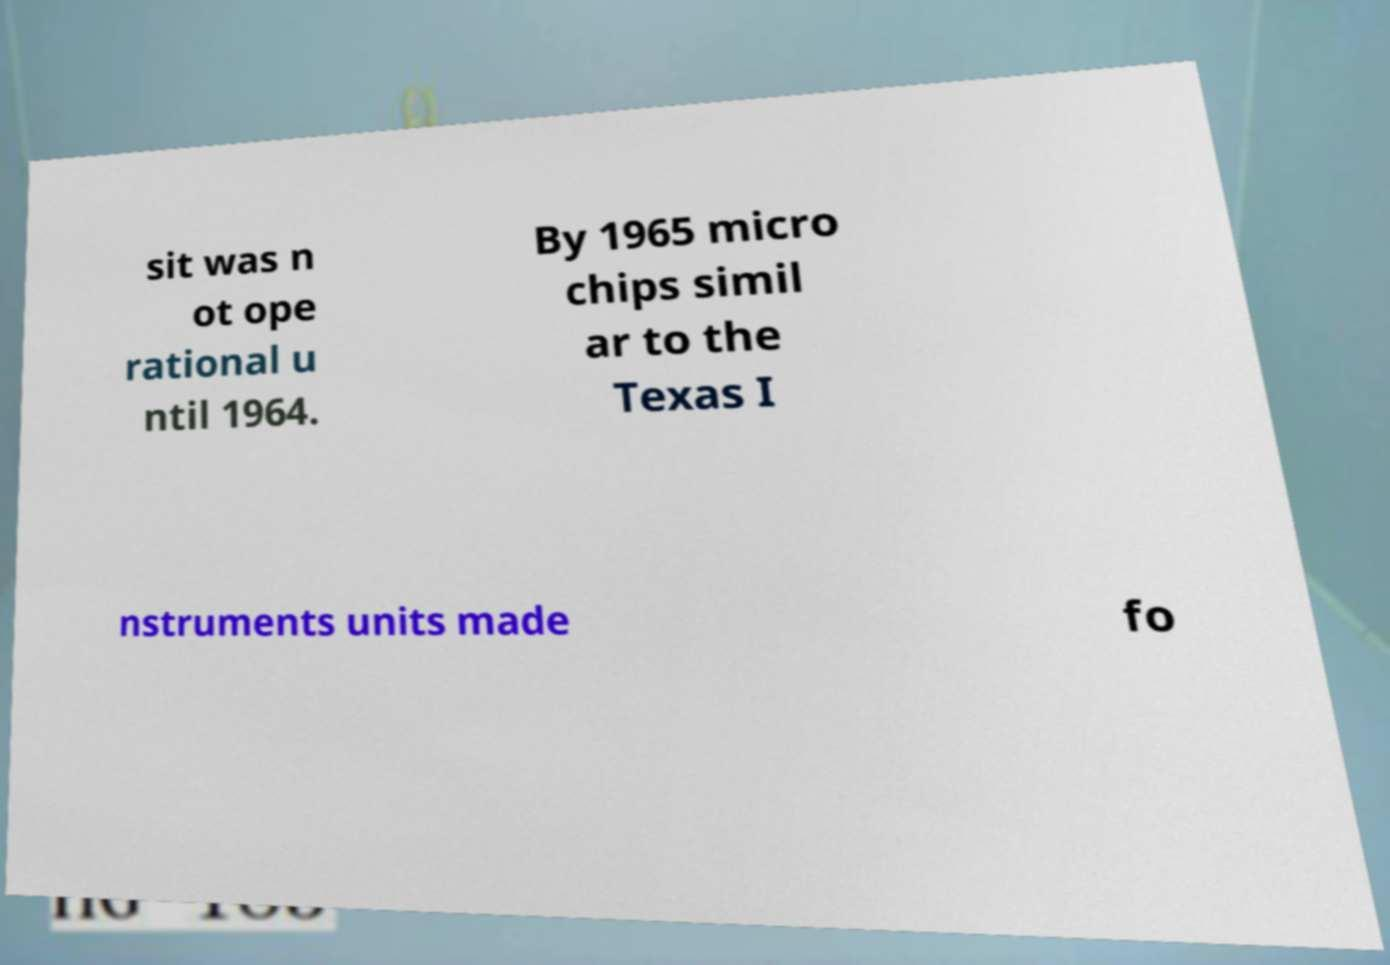Please read and relay the text visible in this image. What does it say? sit was n ot ope rational u ntil 1964. By 1965 micro chips simil ar to the Texas I nstruments units made fo 